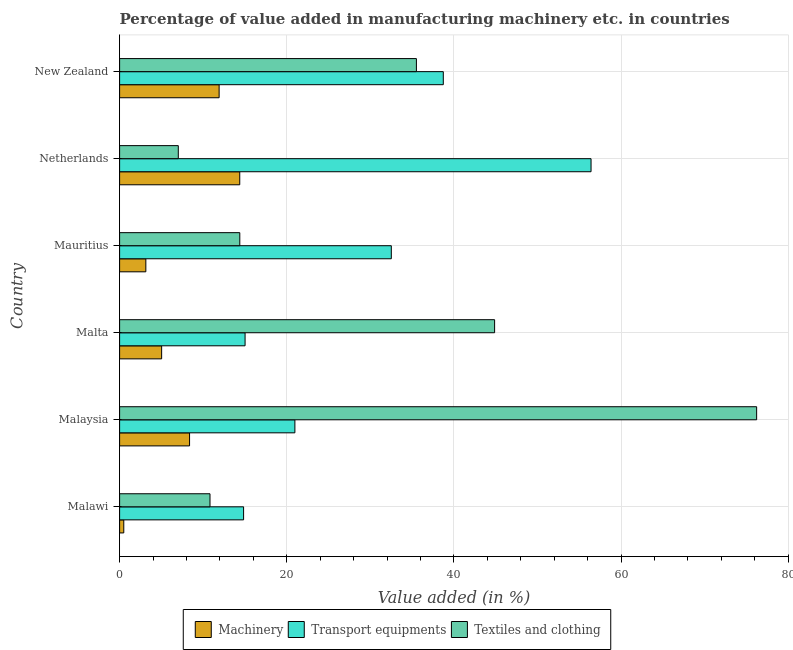Are the number of bars on each tick of the Y-axis equal?
Ensure brevity in your answer.  Yes. How many bars are there on the 2nd tick from the bottom?
Offer a terse response. 3. What is the label of the 1st group of bars from the top?
Your answer should be very brief. New Zealand. In how many cases, is the number of bars for a given country not equal to the number of legend labels?
Your answer should be compact. 0. What is the value added in manufacturing machinery in New Zealand?
Your answer should be compact. 11.91. Across all countries, what is the maximum value added in manufacturing textile and clothing?
Keep it short and to the point. 76.23. Across all countries, what is the minimum value added in manufacturing machinery?
Your answer should be compact. 0.5. What is the total value added in manufacturing machinery in the graph?
Ensure brevity in your answer.  43.33. What is the difference between the value added in manufacturing machinery in Netherlands and that in New Zealand?
Provide a short and direct response. 2.47. What is the difference between the value added in manufacturing textile and clothing in New Zealand and the value added in manufacturing machinery in Mauritius?
Provide a short and direct response. 32.37. What is the average value added in manufacturing transport equipments per country?
Offer a terse response. 29.75. What is the difference between the value added in manufacturing transport equipments and value added in manufacturing textile and clothing in Malta?
Your response must be concise. -29.86. In how many countries, is the value added in manufacturing machinery greater than 4 %?
Ensure brevity in your answer.  4. What is the ratio of the value added in manufacturing transport equipments in Malawi to that in Malaysia?
Offer a very short reply. 0.71. What is the difference between the highest and the second highest value added in manufacturing machinery?
Your answer should be very brief. 2.47. What is the difference between the highest and the lowest value added in manufacturing transport equipments?
Your response must be concise. 41.58. In how many countries, is the value added in manufacturing machinery greater than the average value added in manufacturing machinery taken over all countries?
Your answer should be very brief. 3. What does the 3rd bar from the top in Malta represents?
Offer a terse response. Machinery. What does the 2nd bar from the bottom in Malawi represents?
Your answer should be very brief. Transport equipments. How many bars are there?
Offer a very short reply. 18. What is the difference between two consecutive major ticks on the X-axis?
Your answer should be very brief. 20. Does the graph contain any zero values?
Keep it short and to the point. No. Where does the legend appear in the graph?
Provide a short and direct response. Bottom center. How many legend labels are there?
Your response must be concise. 3. How are the legend labels stacked?
Keep it short and to the point. Horizontal. What is the title of the graph?
Provide a succinct answer. Percentage of value added in manufacturing machinery etc. in countries. Does "Male employers" appear as one of the legend labels in the graph?
Provide a succinct answer. No. What is the label or title of the X-axis?
Your response must be concise. Value added (in %). What is the label or title of the Y-axis?
Offer a terse response. Country. What is the Value added (in %) in Machinery in Malawi?
Make the answer very short. 0.5. What is the Value added (in %) of Transport equipments in Malawi?
Ensure brevity in your answer.  14.84. What is the Value added (in %) of Textiles and clothing in Malawi?
Your response must be concise. 10.82. What is the Value added (in %) in Machinery in Malaysia?
Keep it short and to the point. 8.37. What is the Value added (in %) of Transport equipments in Malaysia?
Your response must be concise. 20.97. What is the Value added (in %) of Textiles and clothing in Malaysia?
Your answer should be very brief. 76.23. What is the Value added (in %) in Machinery in Malta?
Keep it short and to the point. 5.03. What is the Value added (in %) in Transport equipments in Malta?
Your response must be concise. 15.01. What is the Value added (in %) in Textiles and clothing in Malta?
Make the answer very short. 44.87. What is the Value added (in %) of Machinery in Mauritius?
Offer a very short reply. 3.14. What is the Value added (in %) of Transport equipments in Mauritius?
Offer a terse response. 32.51. What is the Value added (in %) of Textiles and clothing in Mauritius?
Keep it short and to the point. 14.38. What is the Value added (in %) in Machinery in Netherlands?
Offer a terse response. 14.38. What is the Value added (in %) in Transport equipments in Netherlands?
Make the answer very short. 56.41. What is the Value added (in %) of Textiles and clothing in Netherlands?
Provide a succinct answer. 7.02. What is the Value added (in %) of Machinery in New Zealand?
Provide a short and direct response. 11.91. What is the Value added (in %) of Transport equipments in New Zealand?
Provide a succinct answer. 38.73. What is the Value added (in %) of Textiles and clothing in New Zealand?
Your answer should be compact. 35.52. Across all countries, what is the maximum Value added (in %) in Machinery?
Provide a succinct answer. 14.38. Across all countries, what is the maximum Value added (in %) in Transport equipments?
Your response must be concise. 56.41. Across all countries, what is the maximum Value added (in %) in Textiles and clothing?
Provide a short and direct response. 76.23. Across all countries, what is the minimum Value added (in %) of Machinery?
Provide a succinct answer. 0.5. Across all countries, what is the minimum Value added (in %) of Transport equipments?
Your response must be concise. 14.84. Across all countries, what is the minimum Value added (in %) of Textiles and clothing?
Your response must be concise. 7.02. What is the total Value added (in %) of Machinery in the graph?
Offer a very short reply. 43.33. What is the total Value added (in %) of Transport equipments in the graph?
Your answer should be compact. 178.48. What is the total Value added (in %) of Textiles and clothing in the graph?
Provide a short and direct response. 188.84. What is the difference between the Value added (in %) of Machinery in Malawi and that in Malaysia?
Provide a short and direct response. -7.87. What is the difference between the Value added (in %) in Transport equipments in Malawi and that in Malaysia?
Provide a short and direct response. -6.14. What is the difference between the Value added (in %) of Textiles and clothing in Malawi and that in Malaysia?
Give a very brief answer. -65.41. What is the difference between the Value added (in %) of Machinery in Malawi and that in Malta?
Ensure brevity in your answer.  -4.53. What is the difference between the Value added (in %) in Transport equipments in Malawi and that in Malta?
Make the answer very short. -0.18. What is the difference between the Value added (in %) in Textiles and clothing in Malawi and that in Malta?
Provide a succinct answer. -34.06. What is the difference between the Value added (in %) of Machinery in Malawi and that in Mauritius?
Keep it short and to the point. -2.64. What is the difference between the Value added (in %) in Transport equipments in Malawi and that in Mauritius?
Make the answer very short. -17.68. What is the difference between the Value added (in %) in Textiles and clothing in Malawi and that in Mauritius?
Provide a succinct answer. -3.57. What is the difference between the Value added (in %) in Machinery in Malawi and that in Netherlands?
Provide a succinct answer. -13.88. What is the difference between the Value added (in %) of Transport equipments in Malawi and that in Netherlands?
Ensure brevity in your answer.  -41.58. What is the difference between the Value added (in %) in Textiles and clothing in Malawi and that in Netherlands?
Provide a succinct answer. 3.79. What is the difference between the Value added (in %) of Machinery in Malawi and that in New Zealand?
Provide a succinct answer. -11.41. What is the difference between the Value added (in %) of Transport equipments in Malawi and that in New Zealand?
Your response must be concise. -23.9. What is the difference between the Value added (in %) of Textiles and clothing in Malawi and that in New Zealand?
Your answer should be very brief. -24.7. What is the difference between the Value added (in %) of Machinery in Malaysia and that in Malta?
Offer a terse response. 3.34. What is the difference between the Value added (in %) of Transport equipments in Malaysia and that in Malta?
Provide a short and direct response. 5.96. What is the difference between the Value added (in %) of Textiles and clothing in Malaysia and that in Malta?
Your answer should be compact. 31.35. What is the difference between the Value added (in %) of Machinery in Malaysia and that in Mauritius?
Offer a terse response. 5.23. What is the difference between the Value added (in %) of Transport equipments in Malaysia and that in Mauritius?
Your answer should be very brief. -11.54. What is the difference between the Value added (in %) in Textiles and clothing in Malaysia and that in Mauritius?
Make the answer very short. 61.85. What is the difference between the Value added (in %) of Machinery in Malaysia and that in Netherlands?
Provide a succinct answer. -6. What is the difference between the Value added (in %) in Transport equipments in Malaysia and that in Netherlands?
Provide a short and direct response. -35.44. What is the difference between the Value added (in %) of Textiles and clothing in Malaysia and that in Netherlands?
Your response must be concise. 69.2. What is the difference between the Value added (in %) of Machinery in Malaysia and that in New Zealand?
Ensure brevity in your answer.  -3.54. What is the difference between the Value added (in %) in Transport equipments in Malaysia and that in New Zealand?
Offer a very short reply. -17.76. What is the difference between the Value added (in %) in Textiles and clothing in Malaysia and that in New Zealand?
Give a very brief answer. 40.71. What is the difference between the Value added (in %) of Machinery in Malta and that in Mauritius?
Make the answer very short. 1.89. What is the difference between the Value added (in %) in Transport equipments in Malta and that in Mauritius?
Offer a terse response. -17.5. What is the difference between the Value added (in %) in Textiles and clothing in Malta and that in Mauritius?
Keep it short and to the point. 30.49. What is the difference between the Value added (in %) in Machinery in Malta and that in Netherlands?
Your response must be concise. -9.35. What is the difference between the Value added (in %) of Transport equipments in Malta and that in Netherlands?
Keep it short and to the point. -41.4. What is the difference between the Value added (in %) of Textiles and clothing in Malta and that in Netherlands?
Offer a very short reply. 37.85. What is the difference between the Value added (in %) in Machinery in Malta and that in New Zealand?
Your answer should be very brief. -6.88. What is the difference between the Value added (in %) in Transport equipments in Malta and that in New Zealand?
Your answer should be very brief. -23.72. What is the difference between the Value added (in %) in Textiles and clothing in Malta and that in New Zealand?
Your answer should be very brief. 9.36. What is the difference between the Value added (in %) in Machinery in Mauritius and that in Netherlands?
Your answer should be compact. -11.24. What is the difference between the Value added (in %) in Transport equipments in Mauritius and that in Netherlands?
Provide a short and direct response. -23.9. What is the difference between the Value added (in %) in Textiles and clothing in Mauritius and that in Netherlands?
Your response must be concise. 7.36. What is the difference between the Value added (in %) in Machinery in Mauritius and that in New Zealand?
Offer a terse response. -8.77. What is the difference between the Value added (in %) in Transport equipments in Mauritius and that in New Zealand?
Offer a terse response. -6.22. What is the difference between the Value added (in %) of Textiles and clothing in Mauritius and that in New Zealand?
Provide a succinct answer. -21.13. What is the difference between the Value added (in %) of Machinery in Netherlands and that in New Zealand?
Ensure brevity in your answer.  2.47. What is the difference between the Value added (in %) of Transport equipments in Netherlands and that in New Zealand?
Offer a very short reply. 17.68. What is the difference between the Value added (in %) in Textiles and clothing in Netherlands and that in New Zealand?
Your answer should be compact. -28.49. What is the difference between the Value added (in %) in Machinery in Malawi and the Value added (in %) in Transport equipments in Malaysia?
Your response must be concise. -20.47. What is the difference between the Value added (in %) of Machinery in Malawi and the Value added (in %) of Textiles and clothing in Malaysia?
Give a very brief answer. -75.73. What is the difference between the Value added (in %) in Transport equipments in Malawi and the Value added (in %) in Textiles and clothing in Malaysia?
Your answer should be compact. -61.39. What is the difference between the Value added (in %) in Machinery in Malawi and the Value added (in %) in Transport equipments in Malta?
Provide a short and direct response. -14.51. What is the difference between the Value added (in %) of Machinery in Malawi and the Value added (in %) of Textiles and clothing in Malta?
Give a very brief answer. -44.37. What is the difference between the Value added (in %) of Transport equipments in Malawi and the Value added (in %) of Textiles and clothing in Malta?
Keep it short and to the point. -30.04. What is the difference between the Value added (in %) of Machinery in Malawi and the Value added (in %) of Transport equipments in Mauritius?
Offer a terse response. -32.01. What is the difference between the Value added (in %) of Machinery in Malawi and the Value added (in %) of Textiles and clothing in Mauritius?
Your answer should be very brief. -13.88. What is the difference between the Value added (in %) of Transport equipments in Malawi and the Value added (in %) of Textiles and clothing in Mauritius?
Your response must be concise. 0.46. What is the difference between the Value added (in %) in Machinery in Malawi and the Value added (in %) in Transport equipments in Netherlands?
Give a very brief answer. -55.91. What is the difference between the Value added (in %) of Machinery in Malawi and the Value added (in %) of Textiles and clothing in Netherlands?
Your answer should be very brief. -6.52. What is the difference between the Value added (in %) in Transport equipments in Malawi and the Value added (in %) in Textiles and clothing in Netherlands?
Give a very brief answer. 7.81. What is the difference between the Value added (in %) of Machinery in Malawi and the Value added (in %) of Transport equipments in New Zealand?
Make the answer very short. -38.23. What is the difference between the Value added (in %) of Machinery in Malawi and the Value added (in %) of Textiles and clothing in New Zealand?
Provide a short and direct response. -35.02. What is the difference between the Value added (in %) of Transport equipments in Malawi and the Value added (in %) of Textiles and clothing in New Zealand?
Give a very brief answer. -20.68. What is the difference between the Value added (in %) in Machinery in Malaysia and the Value added (in %) in Transport equipments in Malta?
Your response must be concise. -6.64. What is the difference between the Value added (in %) of Machinery in Malaysia and the Value added (in %) of Textiles and clothing in Malta?
Give a very brief answer. -36.5. What is the difference between the Value added (in %) of Transport equipments in Malaysia and the Value added (in %) of Textiles and clothing in Malta?
Offer a terse response. -23.9. What is the difference between the Value added (in %) in Machinery in Malaysia and the Value added (in %) in Transport equipments in Mauritius?
Your answer should be compact. -24.14. What is the difference between the Value added (in %) of Machinery in Malaysia and the Value added (in %) of Textiles and clothing in Mauritius?
Ensure brevity in your answer.  -6.01. What is the difference between the Value added (in %) in Transport equipments in Malaysia and the Value added (in %) in Textiles and clothing in Mauritius?
Keep it short and to the point. 6.59. What is the difference between the Value added (in %) of Machinery in Malaysia and the Value added (in %) of Transport equipments in Netherlands?
Provide a succinct answer. -48.04. What is the difference between the Value added (in %) in Machinery in Malaysia and the Value added (in %) in Textiles and clothing in Netherlands?
Your answer should be compact. 1.35. What is the difference between the Value added (in %) in Transport equipments in Malaysia and the Value added (in %) in Textiles and clothing in Netherlands?
Keep it short and to the point. 13.95. What is the difference between the Value added (in %) in Machinery in Malaysia and the Value added (in %) in Transport equipments in New Zealand?
Your response must be concise. -30.36. What is the difference between the Value added (in %) in Machinery in Malaysia and the Value added (in %) in Textiles and clothing in New Zealand?
Offer a very short reply. -27.14. What is the difference between the Value added (in %) of Transport equipments in Malaysia and the Value added (in %) of Textiles and clothing in New Zealand?
Keep it short and to the point. -14.54. What is the difference between the Value added (in %) in Machinery in Malta and the Value added (in %) in Transport equipments in Mauritius?
Give a very brief answer. -27.48. What is the difference between the Value added (in %) of Machinery in Malta and the Value added (in %) of Textiles and clothing in Mauritius?
Make the answer very short. -9.35. What is the difference between the Value added (in %) in Transport equipments in Malta and the Value added (in %) in Textiles and clothing in Mauritius?
Offer a very short reply. 0.63. What is the difference between the Value added (in %) in Machinery in Malta and the Value added (in %) in Transport equipments in Netherlands?
Your response must be concise. -51.38. What is the difference between the Value added (in %) of Machinery in Malta and the Value added (in %) of Textiles and clothing in Netherlands?
Your answer should be very brief. -1.99. What is the difference between the Value added (in %) of Transport equipments in Malta and the Value added (in %) of Textiles and clothing in Netherlands?
Make the answer very short. 7.99. What is the difference between the Value added (in %) of Machinery in Malta and the Value added (in %) of Transport equipments in New Zealand?
Your response must be concise. -33.7. What is the difference between the Value added (in %) in Machinery in Malta and the Value added (in %) in Textiles and clothing in New Zealand?
Your answer should be very brief. -30.49. What is the difference between the Value added (in %) of Transport equipments in Malta and the Value added (in %) of Textiles and clothing in New Zealand?
Your answer should be very brief. -20.5. What is the difference between the Value added (in %) of Machinery in Mauritius and the Value added (in %) of Transport equipments in Netherlands?
Keep it short and to the point. -53.27. What is the difference between the Value added (in %) of Machinery in Mauritius and the Value added (in %) of Textiles and clothing in Netherlands?
Offer a very short reply. -3.88. What is the difference between the Value added (in %) of Transport equipments in Mauritius and the Value added (in %) of Textiles and clothing in Netherlands?
Make the answer very short. 25.49. What is the difference between the Value added (in %) in Machinery in Mauritius and the Value added (in %) in Transport equipments in New Zealand?
Your answer should be very brief. -35.59. What is the difference between the Value added (in %) in Machinery in Mauritius and the Value added (in %) in Textiles and clothing in New Zealand?
Give a very brief answer. -32.37. What is the difference between the Value added (in %) of Transport equipments in Mauritius and the Value added (in %) of Textiles and clothing in New Zealand?
Offer a very short reply. -3. What is the difference between the Value added (in %) in Machinery in Netherlands and the Value added (in %) in Transport equipments in New Zealand?
Your response must be concise. -24.36. What is the difference between the Value added (in %) in Machinery in Netherlands and the Value added (in %) in Textiles and clothing in New Zealand?
Your answer should be very brief. -21.14. What is the difference between the Value added (in %) of Transport equipments in Netherlands and the Value added (in %) of Textiles and clothing in New Zealand?
Keep it short and to the point. 20.9. What is the average Value added (in %) in Machinery per country?
Your response must be concise. 7.22. What is the average Value added (in %) of Transport equipments per country?
Give a very brief answer. 29.75. What is the average Value added (in %) in Textiles and clothing per country?
Your answer should be compact. 31.47. What is the difference between the Value added (in %) of Machinery and Value added (in %) of Transport equipments in Malawi?
Offer a terse response. -14.34. What is the difference between the Value added (in %) in Machinery and Value added (in %) in Textiles and clothing in Malawi?
Offer a terse response. -10.32. What is the difference between the Value added (in %) of Transport equipments and Value added (in %) of Textiles and clothing in Malawi?
Keep it short and to the point. 4.02. What is the difference between the Value added (in %) of Machinery and Value added (in %) of Transport equipments in Malaysia?
Keep it short and to the point. -12.6. What is the difference between the Value added (in %) of Machinery and Value added (in %) of Textiles and clothing in Malaysia?
Your answer should be very brief. -67.86. What is the difference between the Value added (in %) in Transport equipments and Value added (in %) in Textiles and clothing in Malaysia?
Provide a short and direct response. -55.25. What is the difference between the Value added (in %) of Machinery and Value added (in %) of Transport equipments in Malta?
Provide a short and direct response. -9.98. What is the difference between the Value added (in %) in Machinery and Value added (in %) in Textiles and clothing in Malta?
Make the answer very short. -39.84. What is the difference between the Value added (in %) of Transport equipments and Value added (in %) of Textiles and clothing in Malta?
Give a very brief answer. -29.86. What is the difference between the Value added (in %) in Machinery and Value added (in %) in Transport equipments in Mauritius?
Your answer should be very brief. -29.37. What is the difference between the Value added (in %) in Machinery and Value added (in %) in Textiles and clothing in Mauritius?
Give a very brief answer. -11.24. What is the difference between the Value added (in %) of Transport equipments and Value added (in %) of Textiles and clothing in Mauritius?
Ensure brevity in your answer.  18.13. What is the difference between the Value added (in %) of Machinery and Value added (in %) of Transport equipments in Netherlands?
Offer a terse response. -42.04. What is the difference between the Value added (in %) of Machinery and Value added (in %) of Textiles and clothing in Netherlands?
Offer a very short reply. 7.35. What is the difference between the Value added (in %) in Transport equipments and Value added (in %) in Textiles and clothing in Netherlands?
Ensure brevity in your answer.  49.39. What is the difference between the Value added (in %) of Machinery and Value added (in %) of Transport equipments in New Zealand?
Offer a very short reply. -26.82. What is the difference between the Value added (in %) of Machinery and Value added (in %) of Textiles and clothing in New Zealand?
Give a very brief answer. -23.61. What is the difference between the Value added (in %) of Transport equipments and Value added (in %) of Textiles and clothing in New Zealand?
Ensure brevity in your answer.  3.22. What is the ratio of the Value added (in %) of Machinery in Malawi to that in Malaysia?
Make the answer very short. 0.06. What is the ratio of the Value added (in %) of Transport equipments in Malawi to that in Malaysia?
Provide a short and direct response. 0.71. What is the ratio of the Value added (in %) in Textiles and clothing in Malawi to that in Malaysia?
Offer a very short reply. 0.14. What is the ratio of the Value added (in %) in Machinery in Malawi to that in Malta?
Your response must be concise. 0.1. What is the ratio of the Value added (in %) in Textiles and clothing in Malawi to that in Malta?
Give a very brief answer. 0.24. What is the ratio of the Value added (in %) of Machinery in Malawi to that in Mauritius?
Your answer should be compact. 0.16. What is the ratio of the Value added (in %) in Transport equipments in Malawi to that in Mauritius?
Keep it short and to the point. 0.46. What is the ratio of the Value added (in %) of Textiles and clothing in Malawi to that in Mauritius?
Make the answer very short. 0.75. What is the ratio of the Value added (in %) of Machinery in Malawi to that in Netherlands?
Make the answer very short. 0.03. What is the ratio of the Value added (in %) in Transport equipments in Malawi to that in Netherlands?
Offer a very short reply. 0.26. What is the ratio of the Value added (in %) in Textiles and clothing in Malawi to that in Netherlands?
Offer a terse response. 1.54. What is the ratio of the Value added (in %) in Machinery in Malawi to that in New Zealand?
Your response must be concise. 0.04. What is the ratio of the Value added (in %) of Transport equipments in Malawi to that in New Zealand?
Give a very brief answer. 0.38. What is the ratio of the Value added (in %) in Textiles and clothing in Malawi to that in New Zealand?
Offer a very short reply. 0.3. What is the ratio of the Value added (in %) of Machinery in Malaysia to that in Malta?
Ensure brevity in your answer.  1.66. What is the ratio of the Value added (in %) of Transport equipments in Malaysia to that in Malta?
Your answer should be very brief. 1.4. What is the ratio of the Value added (in %) of Textiles and clothing in Malaysia to that in Malta?
Your answer should be very brief. 1.7. What is the ratio of the Value added (in %) of Machinery in Malaysia to that in Mauritius?
Keep it short and to the point. 2.67. What is the ratio of the Value added (in %) in Transport equipments in Malaysia to that in Mauritius?
Provide a short and direct response. 0.65. What is the ratio of the Value added (in %) of Textiles and clothing in Malaysia to that in Mauritius?
Your answer should be compact. 5.3. What is the ratio of the Value added (in %) of Machinery in Malaysia to that in Netherlands?
Provide a succinct answer. 0.58. What is the ratio of the Value added (in %) in Transport equipments in Malaysia to that in Netherlands?
Offer a very short reply. 0.37. What is the ratio of the Value added (in %) in Textiles and clothing in Malaysia to that in Netherlands?
Offer a very short reply. 10.85. What is the ratio of the Value added (in %) of Machinery in Malaysia to that in New Zealand?
Your response must be concise. 0.7. What is the ratio of the Value added (in %) in Transport equipments in Malaysia to that in New Zealand?
Offer a terse response. 0.54. What is the ratio of the Value added (in %) in Textiles and clothing in Malaysia to that in New Zealand?
Provide a succinct answer. 2.15. What is the ratio of the Value added (in %) in Machinery in Malta to that in Mauritius?
Provide a short and direct response. 1.6. What is the ratio of the Value added (in %) in Transport equipments in Malta to that in Mauritius?
Provide a succinct answer. 0.46. What is the ratio of the Value added (in %) in Textiles and clothing in Malta to that in Mauritius?
Give a very brief answer. 3.12. What is the ratio of the Value added (in %) of Machinery in Malta to that in Netherlands?
Provide a succinct answer. 0.35. What is the ratio of the Value added (in %) of Transport equipments in Malta to that in Netherlands?
Give a very brief answer. 0.27. What is the ratio of the Value added (in %) of Textiles and clothing in Malta to that in Netherlands?
Make the answer very short. 6.39. What is the ratio of the Value added (in %) in Machinery in Malta to that in New Zealand?
Provide a succinct answer. 0.42. What is the ratio of the Value added (in %) in Transport equipments in Malta to that in New Zealand?
Your answer should be very brief. 0.39. What is the ratio of the Value added (in %) in Textiles and clothing in Malta to that in New Zealand?
Give a very brief answer. 1.26. What is the ratio of the Value added (in %) of Machinery in Mauritius to that in Netherlands?
Keep it short and to the point. 0.22. What is the ratio of the Value added (in %) of Transport equipments in Mauritius to that in Netherlands?
Provide a succinct answer. 0.58. What is the ratio of the Value added (in %) in Textiles and clothing in Mauritius to that in Netherlands?
Provide a succinct answer. 2.05. What is the ratio of the Value added (in %) of Machinery in Mauritius to that in New Zealand?
Offer a terse response. 0.26. What is the ratio of the Value added (in %) in Transport equipments in Mauritius to that in New Zealand?
Make the answer very short. 0.84. What is the ratio of the Value added (in %) of Textiles and clothing in Mauritius to that in New Zealand?
Your response must be concise. 0.4. What is the ratio of the Value added (in %) in Machinery in Netherlands to that in New Zealand?
Make the answer very short. 1.21. What is the ratio of the Value added (in %) in Transport equipments in Netherlands to that in New Zealand?
Your response must be concise. 1.46. What is the ratio of the Value added (in %) in Textiles and clothing in Netherlands to that in New Zealand?
Ensure brevity in your answer.  0.2. What is the difference between the highest and the second highest Value added (in %) of Machinery?
Your answer should be compact. 2.47. What is the difference between the highest and the second highest Value added (in %) of Transport equipments?
Ensure brevity in your answer.  17.68. What is the difference between the highest and the second highest Value added (in %) in Textiles and clothing?
Your answer should be very brief. 31.35. What is the difference between the highest and the lowest Value added (in %) of Machinery?
Offer a very short reply. 13.88. What is the difference between the highest and the lowest Value added (in %) of Transport equipments?
Make the answer very short. 41.58. What is the difference between the highest and the lowest Value added (in %) in Textiles and clothing?
Make the answer very short. 69.2. 